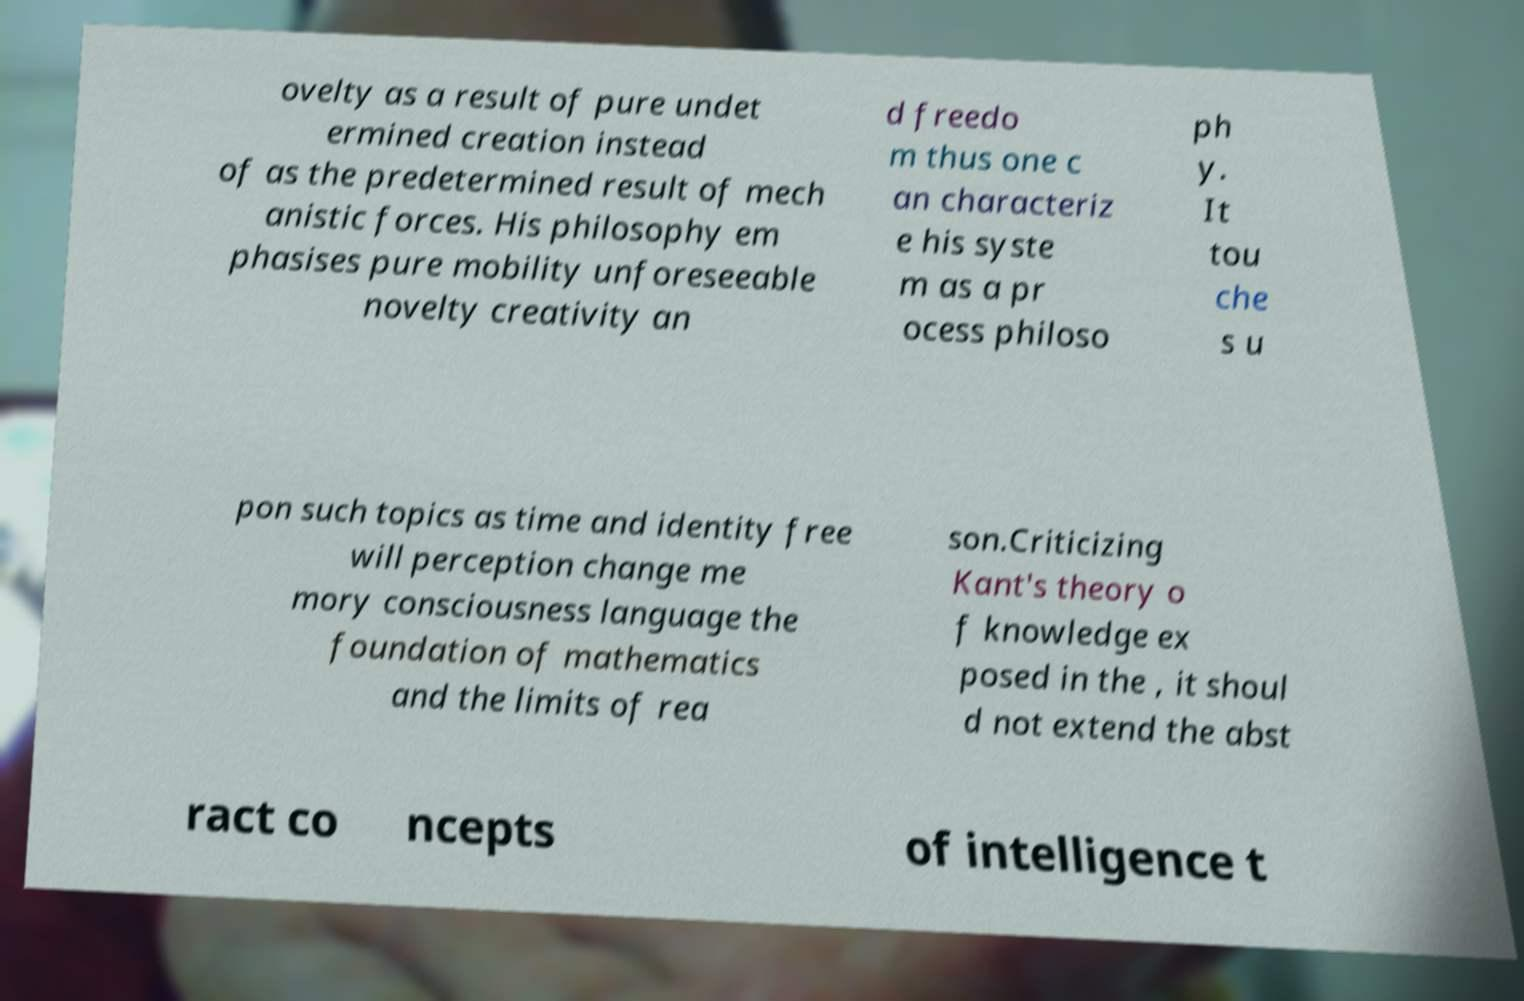I need the written content from this picture converted into text. Can you do that? ovelty as a result of pure undet ermined creation instead of as the predetermined result of mech anistic forces. His philosophy em phasises pure mobility unforeseeable novelty creativity an d freedo m thus one c an characteriz e his syste m as a pr ocess philoso ph y. It tou che s u pon such topics as time and identity free will perception change me mory consciousness language the foundation of mathematics and the limits of rea son.Criticizing Kant's theory o f knowledge ex posed in the , it shoul d not extend the abst ract co ncepts of intelligence t 